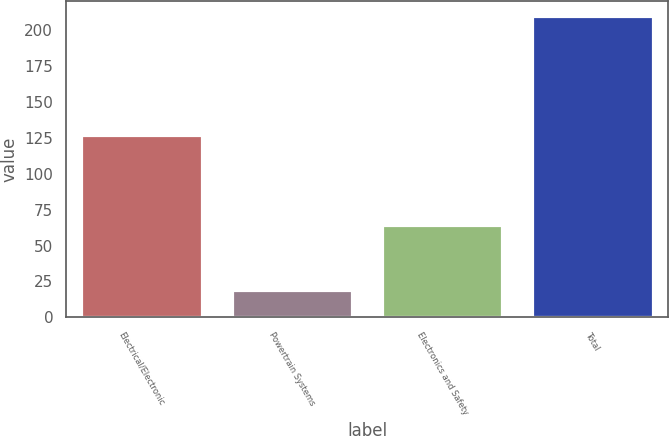<chart> <loc_0><loc_0><loc_500><loc_500><bar_chart><fcel>Electrical/Electronic<fcel>Powertrain Systems<fcel>Electronics and Safety<fcel>Total<nl><fcel>127<fcel>19<fcel>64<fcel>210<nl></chart> 